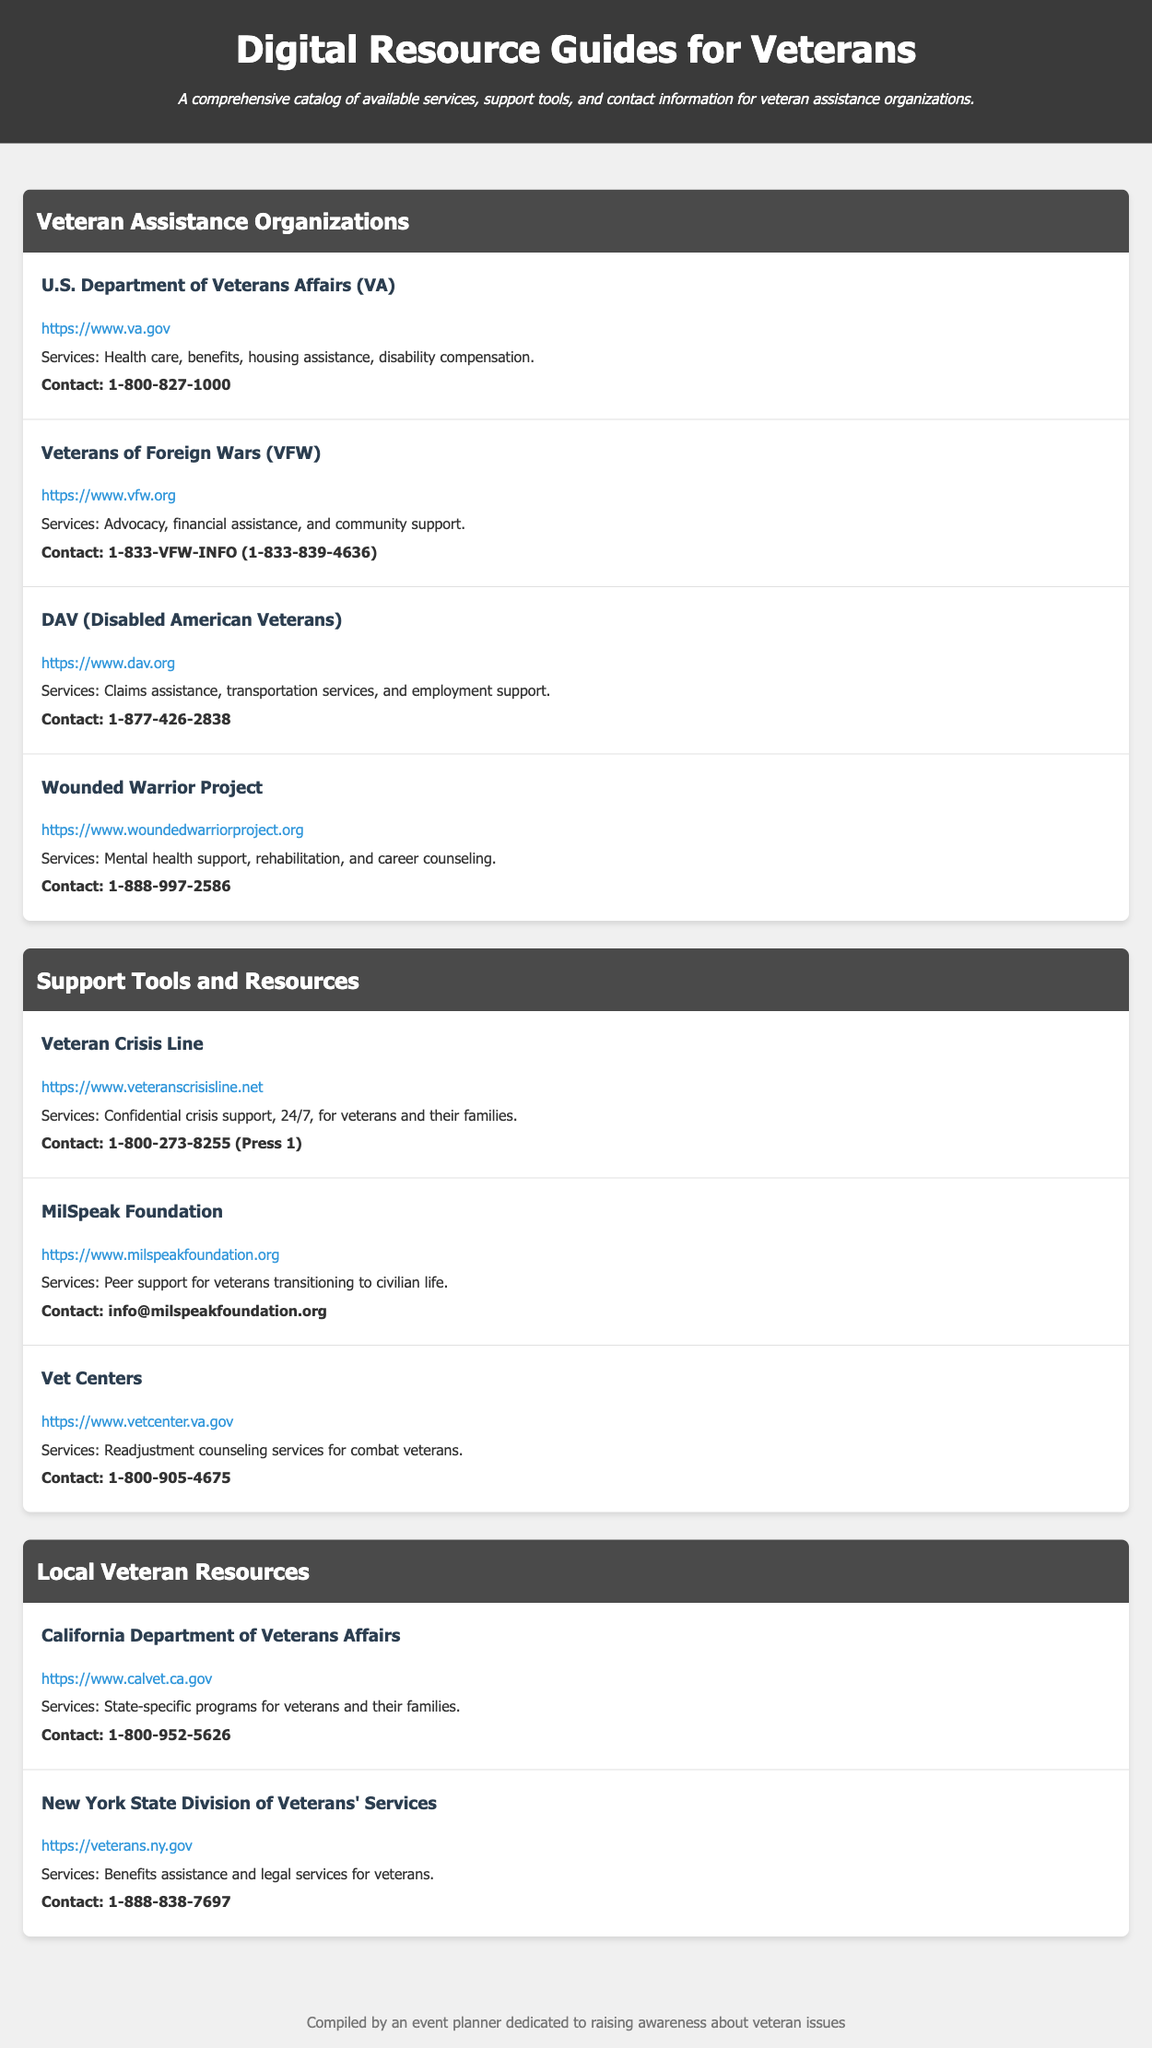What is the website for the U.S. Department of Veterans Affairs? This information is found in the entry for the U.S. Department of Veterans Affairs, which provides a link to their official site.
Answer: https://www.va.gov How many services does the Wounded Warrior Project provide? The entry for the Wounded Warrior Project lists three specific services: Mental health support, rehabilitation, and career counseling.
Answer: 3 What is the contact number for the Veterans of Foreign Wars? The contact number is listed under the Veterans of Foreign Wars entry.
Answer: 1-833-VFW-INFO (1-833-839-4636) Which organization offers peer support for veterans? Peer support is mentioned as a service offered by the MilSpeak Foundation entry.
Answer: MilSpeak Foundation What type of counseling services do Vet Centers provide? The entry for Vet Centers describes their service as readjustment counseling services specifically aimed at combat veterans.
Answer: Readjustment counseling services What is the primary focus of the DAV (Disabled American Veterans)? The entry describes the DAV as focusing on claims assistance, transportation services, and employment support for veterans.
Answer: Claims assistance What kind of interactions does the Veteran Crisis Line provide? The information in the entry indicates that the Veteran Crisis Line provides confidential crisis support, available 24/7 for veterans and their families.
Answer: Crisis support Which state-specific program does the California Department of Veterans Affairs focus on? The services for veterans and their families provided by the California Department of Veterans Affairs are focused on state-specific programs.
Answer: State-specific programs What is the main theme of the document? The document aims to compile a comprehensive catalog of services, support tools, and contact information for veteran assistance organizations.
Answer: Veteran assistance organizations 